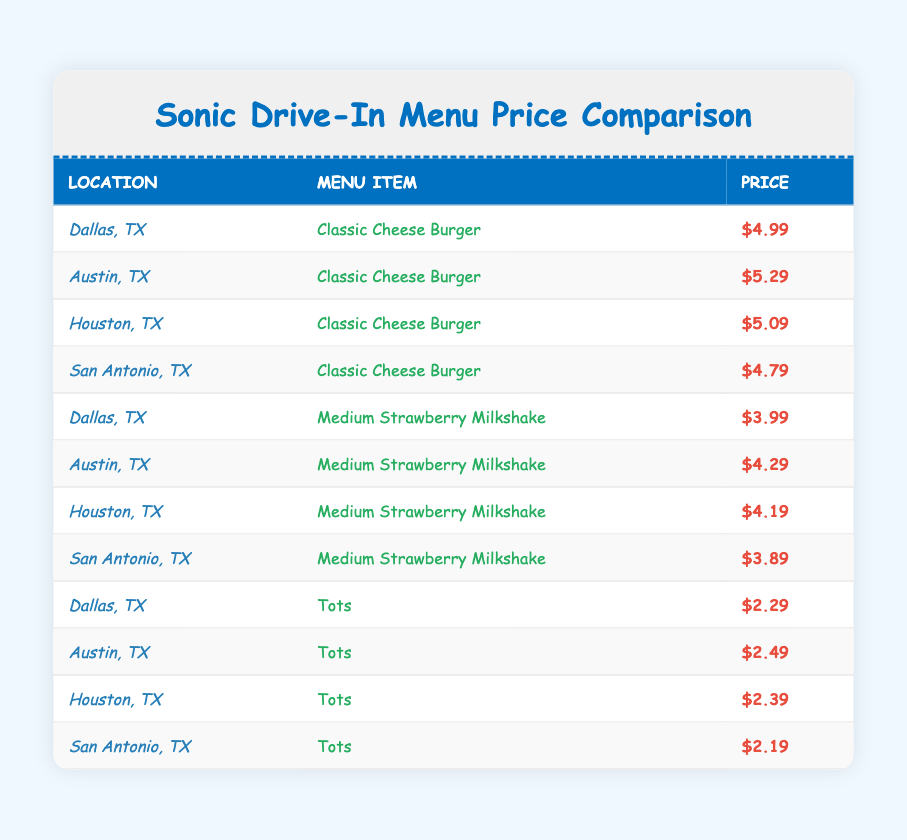What is the price of a Classic Cheese Burger in San Antonio, TX? The table shows the prices of various menu items across different locations, and specifically, the price for a Classic Cheese Burger in San Antonio, TX is listed as $4.79.
Answer: $4.79 Which location has the highest price for the Medium Strawberry Milkshake? By comparing the prices of the Medium Strawberry Milkshake in the table, the highest price is in Austin, TX at $4.29.
Answer: Austin, TX What is the average price of Tots across all locations? The prices for Tots are Dallas ($2.29), Austin ($2.49), Houston ($2.39), and San Antonio ($2.19). Adding these gives a total of $2.29 + $2.49 + $2.39 + $2.19 = $9.36. Dividing by 4 (the number of locations) gives an average of $9.36 / 4 = $2.34.
Answer: $2.34 Is the price of a Medium Strawberry Milkshake in Houston less than in Dallas? The price of a Medium Strawberry Milkshake in Houston is $4.19, while in Dallas it is $3.99. Since $4.19 is greater than $3.99, the statement is false.
Answer: No Which menu item is the cheapest in San Antonio, TX? Looking at the prices of all items in San Antonio, the Classic Cheese Burger is $4.79, the Medium Strawberry Milkshake is $3.89, and the Tots are $2.19. The cheapest item is Tots at $2.19.
Answer: Tots 